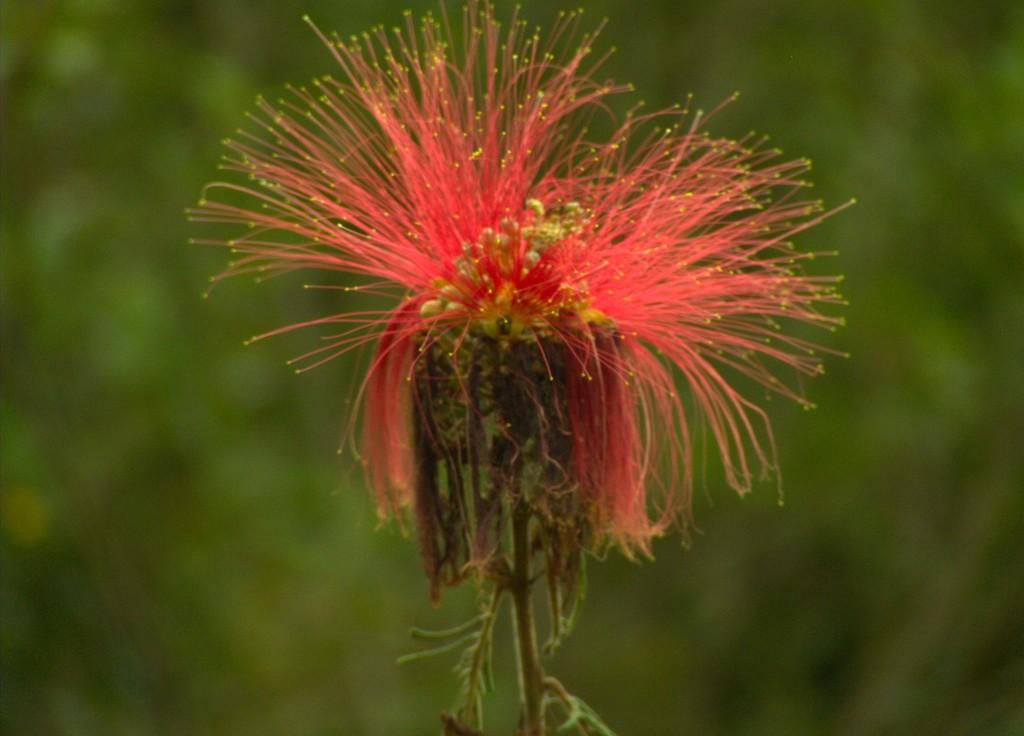What is the main subject of the image? The main subject of the image is a flower. Can you describe the flower's location in the image? The flower is on the stem of a plant. What type of judge is present in the image? There is no judge present in the image; it features a flower on the stem of a plant. How does the flower attack other flowers in the image? Flowers do not have the ability to attack other flowers; they are stationary plants. 